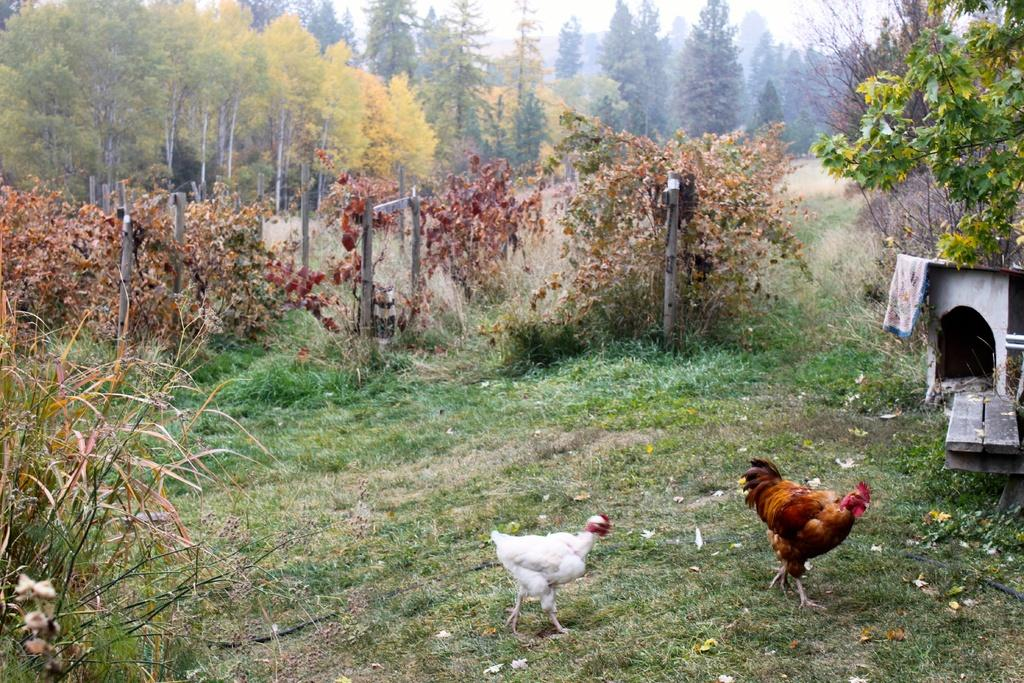What type of animals can be seen on the ground in the image? There are birds on the ground in the image. What can be seen in the background of the image? There are trees in the background of the image. What type of vegetation is on the ground in the image? There is grass on the ground in the image. What type of structure is located on the right side of the image? There is a hut on the right side of the image. What word is written on the rod in the image? There is no rod or word present in the image. What time of day is depicted in the image? The time of day is not specified in the image; it could be morning, afternoon, or evening. 